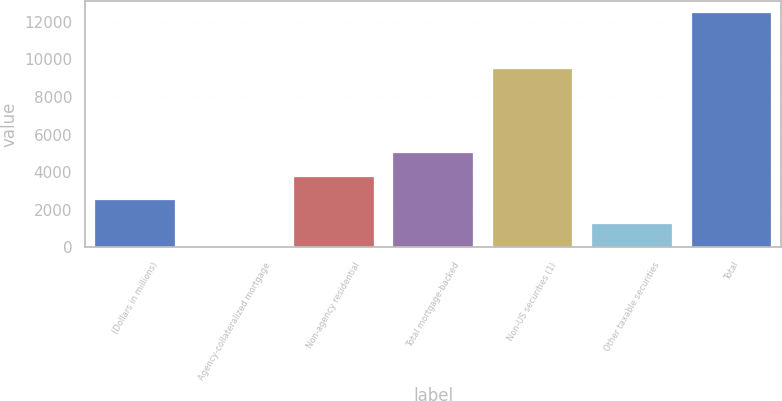Convert chart to OTSL. <chart><loc_0><loc_0><loc_500><loc_500><bar_chart><fcel>(Dollars in millions)<fcel>Agency-collateralized mortgage<fcel>Non-agency residential<fcel>Total mortgage-backed<fcel>Non-US securities (1)<fcel>Other taxable securities<fcel>Total<nl><fcel>2501.2<fcel>5<fcel>3749.3<fcel>4997.4<fcel>9488<fcel>1253.1<fcel>12486<nl></chart> 